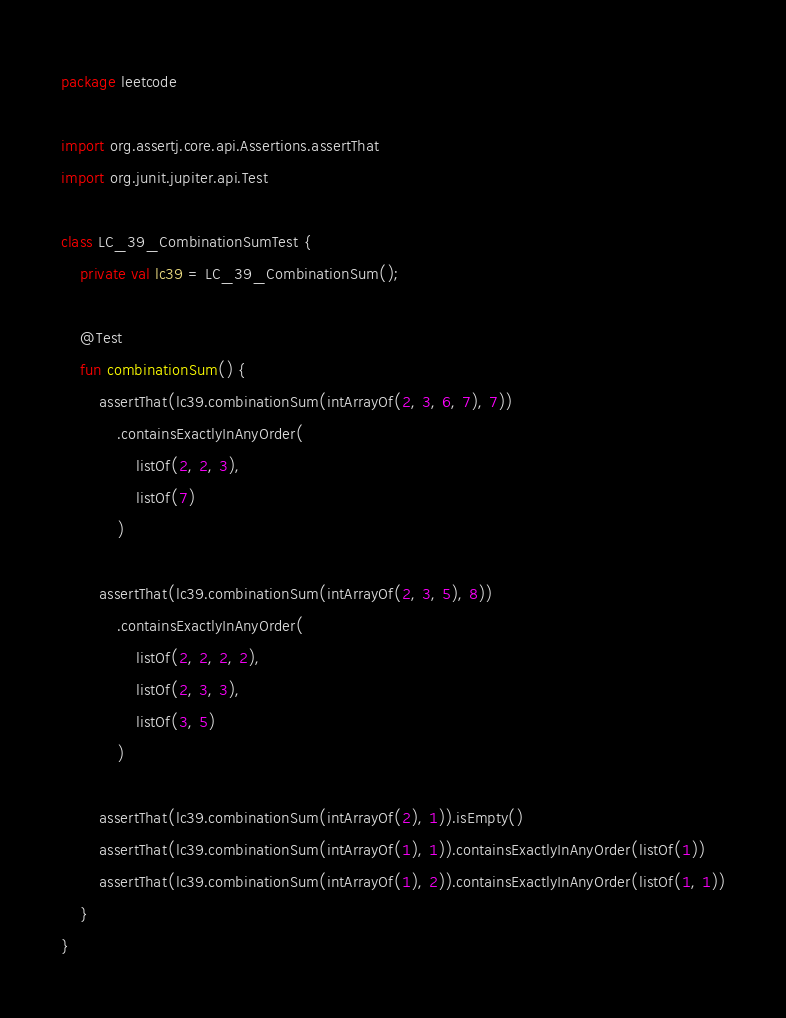Convert code to text. <code><loc_0><loc_0><loc_500><loc_500><_Kotlin_>package leetcode

import org.assertj.core.api.Assertions.assertThat
import org.junit.jupiter.api.Test

class LC_39_CombinationSumTest {
	private val lc39 = LC_39_CombinationSum();

	@Test
	fun combinationSum() {
		assertThat(lc39.combinationSum(intArrayOf(2, 3, 6, 7), 7))
			.containsExactlyInAnyOrder(
				listOf(2, 2, 3),
				listOf(7)
			)

		assertThat(lc39.combinationSum(intArrayOf(2, 3, 5), 8))
			.containsExactlyInAnyOrder(
				listOf(2, 2, 2, 2),
				listOf(2, 3, 3),
				listOf(3, 5)
			)

		assertThat(lc39.combinationSum(intArrayOf(2), 1)).isEmpty()
		assertThat(lc39.combinationSum(intArrayOf(1), 1)).containsExactlyInAnyOrder(listOf(1))
		assertThat(lc39.combinationSum(intArrayOf(1), 2)).containsExactlyInAnyOrder(listOf(1, 1))
	}
}</code> 